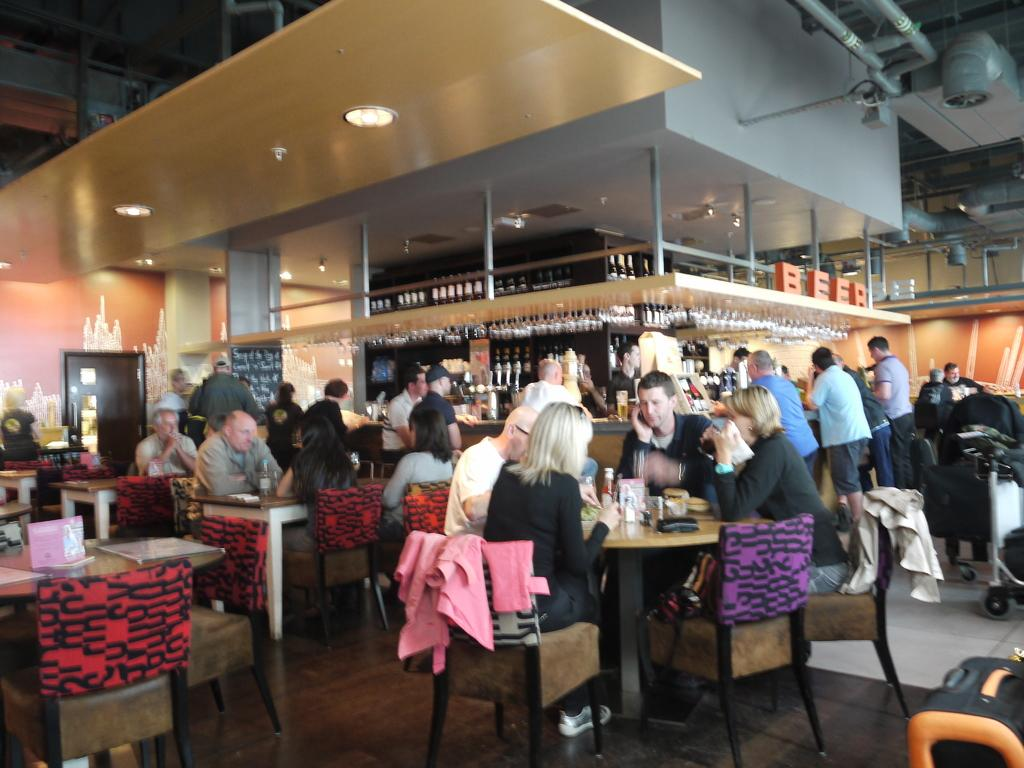What is the main activity of the people in the image? The main activity of the people in the image is sitting in front of a table. Are there any other activities or locations depicted in the image? Yes, some people are standing at a wine shop. What type of volleyball is being played by the people in the image? There is no volleyball being played in the image; the people are sitting at a table and standing at a wine shop. How does the drum contribute to the atmosphere in the image? There is no drum present in the image. 